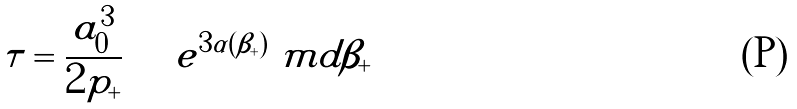Convert formula to latex. <formula><loc_0><loc_0><loc_500><loc_500>\tau = \frac { a _ { 0 } ^ { 3 } } { 2 p _ { + } } \int e ^ { 3 \alpha ( \beta _ { + } ) } \ m d \beta _ { + }</formula> 